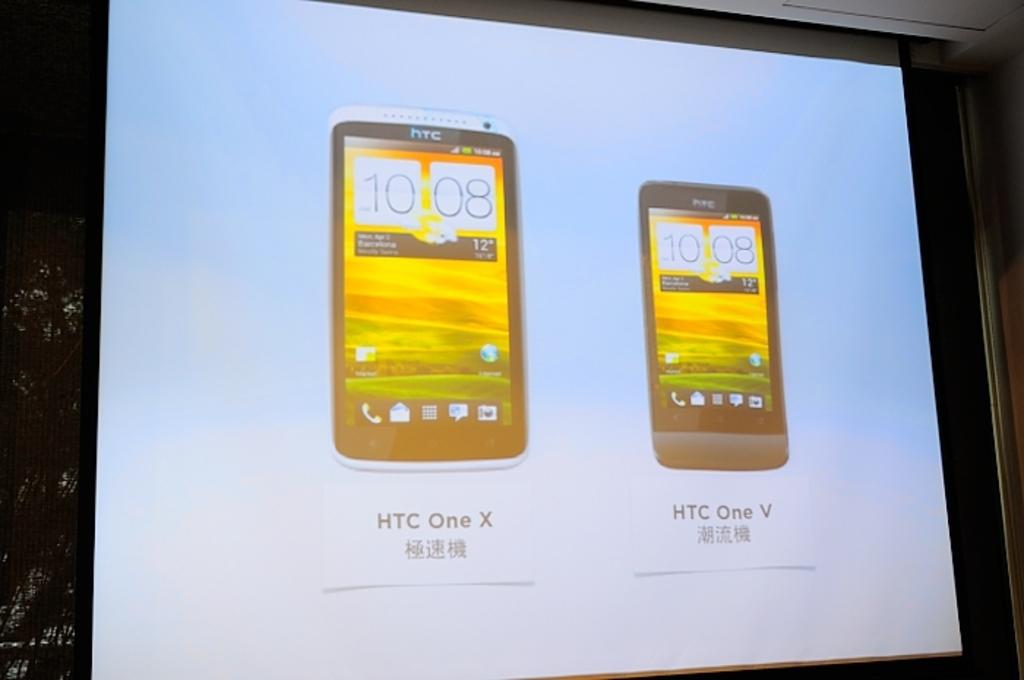<image>
Offer a succinct explanation of the picture presented. A screen image of two HTC branded cell phones. 